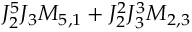<formula> <loc_0><loc_0><loc_500><loc_500>J _ { 2 } ^ { 5 } J _ { 3 } M _ { 5 , 1 } + J _ { 2 } ^ { 2 } J _ { 3 } ^ { 3 } M _ { 2 , 3 }</formula> 